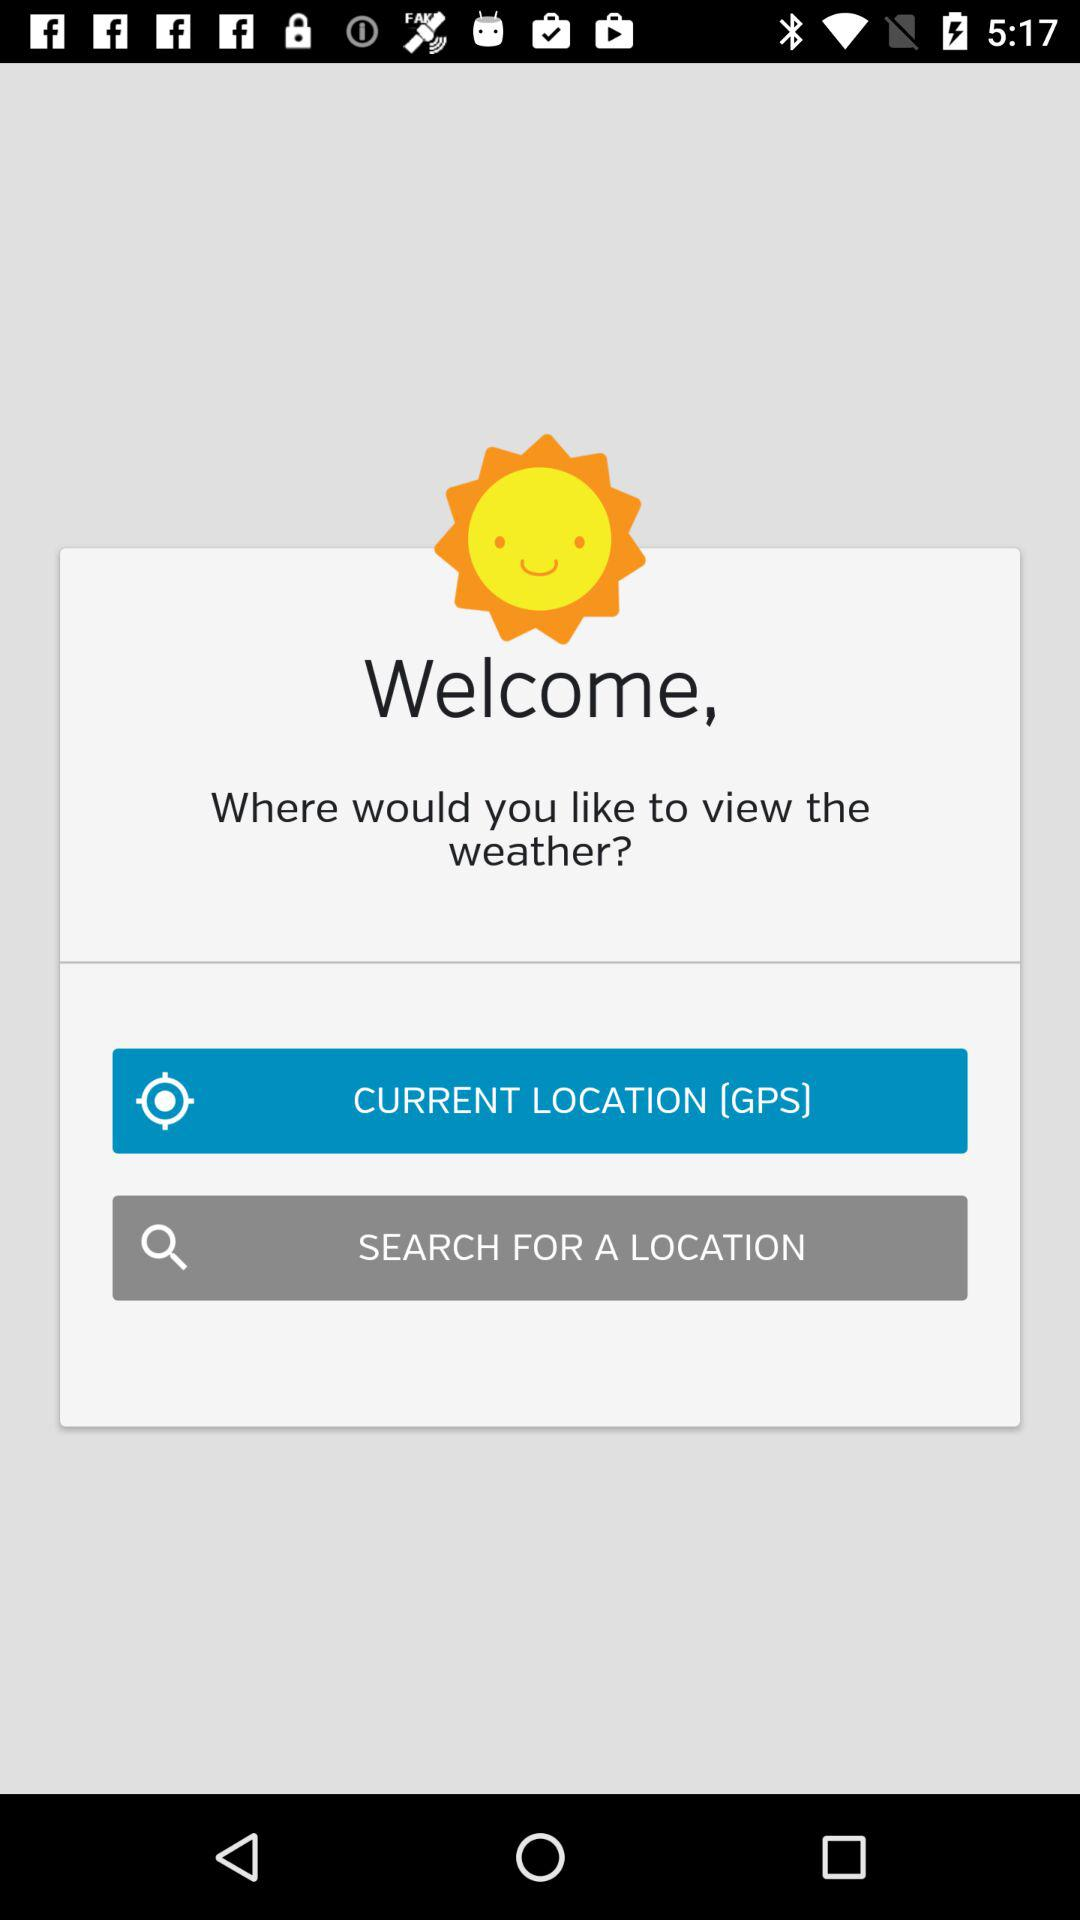Which are the different options to view the weather? The different options to view the weather is "CURRENT LOCATION (GPS)" and "SEARCH FOR A LOCATION". 